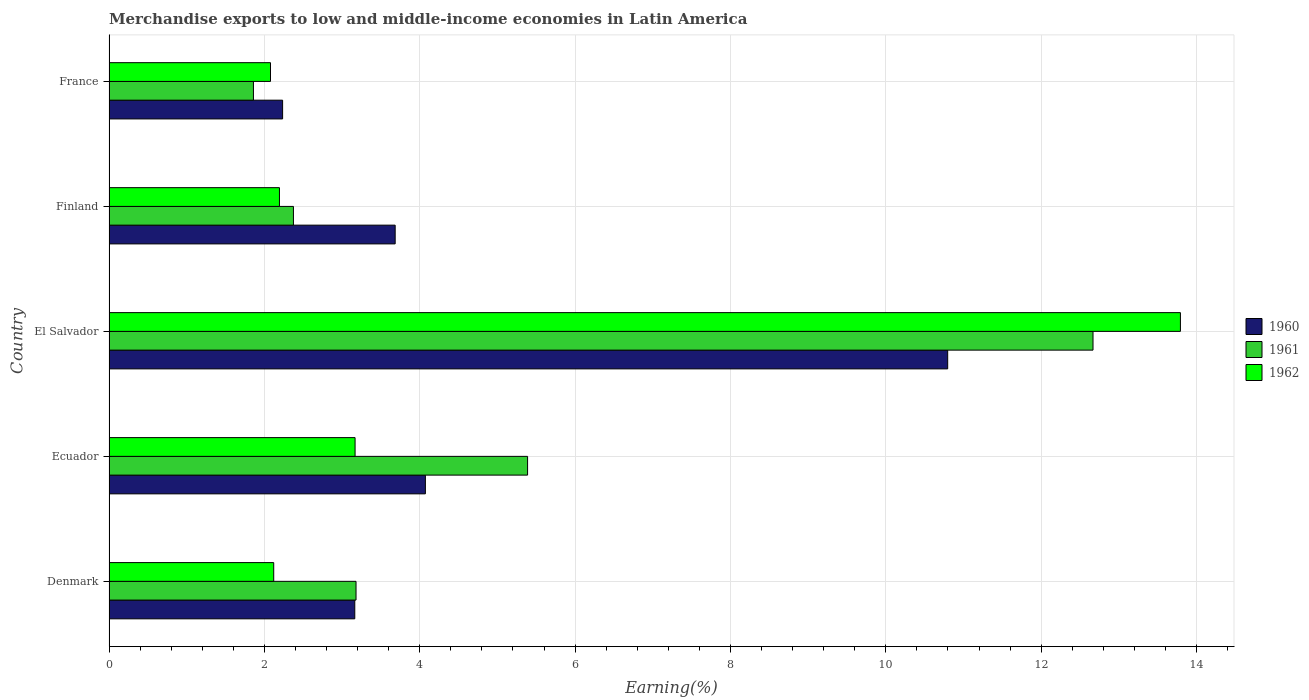How many different coloured bars are there?
Your answer should be compact. 3. Are the number of bars per tick equal to the number of legend labels?
Offer a terse response. Yes. Are the number of bars on each tick of the Y-axis equal?
Offer a very short reply. Yes. How many bars are there on the 3rd tick from the bottom?
Your answer should be compact. 3. In how many cases, is the number of bars for a given country not equal to the number of legend labels?
Provide a succinct answer. 0. What is the percentage of amount earned from merchandise exports in 1961 in Ecuador?
Make the answer very short. 5.39. Across all countries, what is the maximum percentage of amount earned from merchandise exports in 1960?
Make the answer very short. 10.8. Across all countries, what is the minimum percentage of amount earned from merchandise exports in 1961?
Give a very brief answer. 1.86. In which country was the percentage of amount earned from merchandise exports in 1961 maximum?
Your answer should be compact. El Salvador. What is the total percentage of amount earned from merchandise exports in 1962 in the graph?
Offer a terse response. 23.35. What is the difference between the percentage of amount earned from merchandise exports in 1960 in Denmark and that in France?
Provide a short and direct response. 0.93. What is the difference between the percentage of amount earned from merchandise exports in 1962 in El Salvador and the percentage of amount earned from merchandise exports in 1960 in France?
Your answer should be compact. 11.56. What is the average percentage of amount earned from merchandise exports in 1961 per country?
Provide a succinct answer. 5.09. What is the difference between the percentage of amount earned from merchandise exports in 1962 and percentage of amount earned from merchandise exports in 1961 in Ecuador?
Offer a terse response. -2.22. What is the ratio of the percentage of amount earned from merchandise exports in 1960 in Ecuador to that in El Salvador?
Provide a short and direct response. 0.38. Is the percentage of amount earned from merchandise exports in 1961 in Denmark less than that in Ecuador?
Ensure brevity in your answer.  Yes. Is the difference between the percentage of amount earned from merchandise exports in 1962 in Denmark and Ecuador greater than the difference between the percentage of amount earned from merchandise exports in 1961 in Denmark and Ecuador?
Provide a short and direct response. Yes. What is the difference between the highest and the second highest percentage of amount earned from merchandise exports in 1961?
Your answer should be very brief. 7.28. What is the difference between the highest and the lowest percentage of amount earned from merchandise exports in 1961?
Provide a succinct answer. 10.81. What does the 3rd bar from the top in El Salvador represents?
Your answer should be very brief. 1960. What does the 3rd bar from the bottom in Denmark represents?
Provide a short and direct response. 1962. Is it the case that in every country, the sum of the percentage of amount earned from merchandise exports in 1960 and percentage of amount earned from merchandise exports in 1961 is greater than the percentage of amount earned from merchandise exports in 1962?
Offer a terse response. Yes. Are all the bars in the graph horizontal?
Provide a short and direct response. Yes. How many countries are there in the graph?
Provide a succinct answer. 5. What is the difference between two consecutive major ticks on the X-axis?
Your answer should be very brief. 2. Does the graph contain any zero values?
Provide a short and direct response. No. Where does the legend appear in the graph?
Give a very brief answer. Center right. How many legend labels are there?
Ensure brevity in your answer.  3. How are the legend labels stacked?
Your response must be concise. Vertical. What is the title of the graph?
Provide a short and direct response. Merchandise exports to low and middle-income economies in Latin America. Does "1990" appear as one of the legend labels in the graph?
Offer a terse response. No. What is the label or title of the X-axis?
Your answer should be very brief. Earning(%). What is the label or title of the Y-axis?
Your answer should be very brief. Country. What is the Earning(%) of 1960 in Denmark?
Provide a succinct answer. 3.16. What is the Earning(%) in 1961 in Denmark?
Make the answer very short. 3.18. What is the Earning(%) in 1962 in Denmark?
Keep it short and to the point. 2.12. What is the Earning(%) in 1960 in Ecuador?
Ensure brevity in your answer.  4.07. What is the Earning(%) of 1961 in Ecuador?
Make the answer very short. 5.39. What is the Earning(%) in 1962 in Ecuador?
Your answer should be very brief. 3.17. What is the Earning(%) in 1960 in El Salvador?
Offer a terse response. 10.8. What is the Earning(%) of 1961 in El Salvador?
Your answer should be very brief. 12.67. What is the Earning(%) of 1962 in El Salvador?
Provide a short and direct response. 13.79. What is the Earning(%) of 1960 in Finland?
Ensure brevity in your answer.  3.68. What is the Earning(%) in 1961 in Finland?
Your response must be concise. 2.37. What is the Earning(%) of 1962 in Finland?
Offer a very short reply. 2.19. What is the Earning(%) of 1960 in France?
Offer a terse response. 2.23. What is the Earning(%) in 1961 in France?
Ensure brevity in your answer.  1.86. What is the Earning(%) in 1962 in France?
Provide a short and direct response. 2.08. Across all countries, what is the maximum Earning(%) in 1960?
Ensure brevity in your answer.  10.8. Across all countries, what is the maximum Earning(%) of 1961?
Offer a very short reply. 12.67. Across all countries, what is the maximum Earning(%) in 1962?
Ensure brevity in your answer.  13.79. Across all countries, what is the minimum Earning(%) in 1960?
Offer a very short reply. 2.23. Across all countries, what is the minimum Earning(%) in 1961?
Give a very brief answer. 1.86. Across all countries, what is the minimum Earning(%) in 1962?
Offer a terse response. 2.08. What is the total Earning(%) of 1960 in the graph?
Provide a succinct answer. 23.95. What is the total Earning(%) in 1961 in the graph?
Your answer should be very brief. 25.47. What is the total Earning(%) of 1962 in the graph?
Your answer should be very brief. 23.35. What is the difference between the Earning(%) in 1960 in Denmark and that in Ecuador?
Ensure brevity in your answer.  -0.91. What is the difference between the Earning(%) of 1961 in Denmark and that in Ecuador?
Offer a terse response. -2.21. What is the difference between the Earning(%) in 1962 in Denmark and that in Ecuador?
Your response must be concise. -1.05. What is the difference between the Earning(%) of 1960 in Denmark and that in El Salvador?
Offer a terse response. -7.63. What is the difference between the Earning(%) of 1961 in Denmark and that in El Salvador?
Make the answer very short. -9.49. What is the difference between the Earning(%) of 1962 in Denmark and that in El Salvador?
Your response must be concise. -11.67. What is the difference between the Earning(%) in 1960 in Denmark and that in Finland?
Offer a terse response. -0.52. What is the difference between the Earning(%) of 1961 in Denmark and that in Finland?
Your answer should be compact. 0.81. What is the difference between the Earning(%) in 1962 in Denmark and that in Finland?
Make the answer very short. -0.07. What is the difference between the Earning(%) of 1960 in Denmark and that in France?
Give a very brief answer. 0.93. What is the difference between the Earning(%) in 1961 in Denmark and that in France?
Give a very brief answer. 1.32. What is the difference between the Earning(%) in 1962 in Denmark and that in France?
Your response must be concise. 0.04. What is the difference between the Earning(%) of 1960 in Ecuador and that in El Salvador?
Offer a terse response. -6.72. What is the difference between the Earning(%) of 1961 in Ecuador and that in El Salvador?
Your response must be concise. -7.28. What is the difference between the Earning(%) in 1962 in Ecuador and that in El Salvador?
Your answer should be compact. -10.63. What is the difference between the Earning(%) in 1960 in Ecuador and that in Finland?
Offer a very short reply. 0.39. What is the difference between the Earning(%) in 1961 in Ecuador and that in Finland?
Keep it short and to the point. 3.01. What is the difference between the Earning(%) in 1962 in Ecuador and that in Finland?
Keep it short and to the point. 0.97. What is the difference between the Earning(%) of 1960 in Ecuador and that in France?
Offer a very short reply. 1.84. What is the difference between the Earning(%) of 1961 in Ecuador and that in France?
Make the answer very short. 3.53. What is the difference between the Earning(%) of 1962 in Ecuador and that in France?
Your response must be concise. 1.09. What is the difference between the Earning(%) in 1960 in El Salvador and that in Finland?
Keep it short and to the point. 7.11. What is the difference between the Earning(%) of 1961 in El Salvador and that in Finland?
Make the answer very short. 10.29. What is the difference between the Earning(%) in 1962 in El Salvador and that in Finland?
Give a very brief answer. 11.6. What is the difference between the Earning(%) in 1960 in El Salvador and that in France?
Your answer should be very brief. 8.56. What is the difference between the Earning(%) in 1961 in El Salvador and that in France?
Provide a succinct answer. 10.81. What is the difference between the Earning(%) of 1962 in El Salvador and that in France?
Provide a short and direct response. 11.71. What is the difference between the Earning(%) of 1960 in Finland and that in France?
Your answer should be compact. 1.45. What is the difference between the Earning(%) of 1961 in Finland and that in France?
Offer a very short reply. 0.51. What is the difference between the Earning(%) of 1962 in Finland and that in France?
Your response must be concise. 0.12. What is the difference between the Earning(%) of 1960 in Denmark and the Earning(%) of 1961 in Ecuador?
Provide a succinct answer. -2.22. What is the difference between the Earning(%) in 1960 in Denmark and the Earning(%) in 1962 in Ecuador?
Offer a very short reply. -0. What is the difference between the Earning(%) of 1961 in Denmark and the Earning(%) of 1962 in Ecuador?
Your response must be concise. 0.01. What is the difference between the Earning(%) of 1960 in Denmark and the Earning(%) of 1961 in El Salvador?
Provide a short and direct response. -9.5. What is the difference between the Earning(%) in 1960 in Denmark and the Earning(%) in 1962 in El Salvador?
Your response must be concise. -10.63. What is the difference between the Earning(%) of 1961 in Denmark and the Earning(%) of 1962 in El Salvador?
Provide a short and direct response. -10.61. What is the difference between the Earning(%) in 1960 in Denmark and the Earning(%) in 1961 in Finland?
Provide a succinct answer. 0.79. What is the difference between the Earning(%) in 1960 in Denmark and the Earning(%) in 1962 in Finland?
Provide a short and direct response. 0.97. What is the difference between the Earning(%) in 1961 in Denmark and the Earning(%) in 1962 in Finland?
Make the answer very short. 0.99. What is the difference between the Earning(%) in 1960 in Denmark and the Earning(%) in 1961 in France?
Your answer should be very brief. 1.3. What is the difference between the Earning(%) of 1960 in Denmark and the Earning(%) of 1962 in France?
Keep it short and to the point. 1.09. What is the difference between the Earning(%) of 1961 in Denmark and the Earning(%) of 1962 in France?
Provide a short and direct response. 1.1. What is the difference between the Earning(%) of 1960 in Ecuador and the Earning(%) of 1961 in El Salvador?
Make the answer very short. -8.59. What is the difference between the Earning(%) of 1960 in Ecuador and the Earning(%) of 1962 in El Salvador?
Your answer should be very brief. -9.72. What is the difference between the Earning(%) in 1961 in Ecuador and the Earning(%) in 1962 in El Salvador?
Your answer should be very brief. -8.4. What is the difference between the Earning(%) in 1960 in Ecuador and the Earning(%) in 1961 in Finland?
Your response must be concise. 1.7. What is the difference between the Earning(%) of 1960 in Ecuador and the Earning(%) of 1962 in Finland?
Ensure brevity in your answer.  1.88. What is the difference between the Earning(%) of 1961 in Ecuador and the Earning(%) of 1962 in Finland?
Offer a very short reply. 3.19. What is the difference between the Earning(%) of 1960 in Ecuador and the Earning(%) of 1961 in France?
Keep it short and to the point. 2.21. What is the difference between the Earning(%) of 1960 in Ecuador and the Earning(%) of 1962 in France?
Give a very brief answer. 1.99. What is the difference between the Earning(%) of 1961 in Ecuador and the Earning(%) of 1962 in France?
Ensure brevity in your answer.  3.31. What is the difference between the Earning(%) in 1960 in El Salvador and the Earning(%) in 1961 in Finland?
Ensure brevity in your answer.  8.42. What is the difference between the Earning(%) in 1960 in El Salvador and the Earning(%) in 1962 in Finland?
Give a very brief answer. 8.6. What is the difference between the Earning(%) in 1961 in El Salvador and the Earning(%) in 1962 in Finland?
Give a very brief answer. 10.47. What is the difference between the Earning(%) of 1960 in El Salvador and the Earning(%) of 1961 in France?
Make the answer very short. 8.94. What is the difference between the Earning(%) in 1960 in El Salvador and the Earning(%) in 1962 in France?
Provide a succinct answer. 8.72. What is the difference between the Earning(%) in 1961 in El Salvador and the Earning(%) in 1962 in France?
Provide a short and direct response. 10.59. What is the difference between the Earning(%) in 1960 in Finland and the Earning(%) in 1961 in France?
Your response must be concise. 1.82. What is the difference between the Earning(%) of 1960 in Finland and the Earning(%) of 1962 in France?
Offer a terse response. 1.6. What is the difference between the Earning(%) in 1961 in Finland and the Earning(%) in 1962 in France?
Your answer should be very brief. 0.3. What is the average Earning(%) in 1960 per country?
Make the answer very short. 4.79. What is the average Earning(%) in 1961 per country?
Your answer should be very brief. 5.09. What is the average Earning(%) in 1962 per country?
Provide a succinct answer. 4.67. What is the difference between the Earning(%) of 1960 and Earning(%) of 1961 in Denmark?
Keep it short and to the point. -0.02. What is the difference between the Earning(%) of 1960 and Earning(%) of 1962 in Denmark?
Your answer should be very brief. 1.04. What is the difference between the Earning(%) in 1961 and Earning(%) in 1962 in Denmark?
Offer a very short reply. 1.06. What is the difference between the Earning(%) in 1960 and Earning(%) in 1961 in Ecuador?
Your response must be concise. -1.32. What is the difference between the Earning(%) of 1960 and Earning(%) of 1962 in Ecuador?
Ensure brevity in your answer.  0.91. What is the difference between the Earning(%) of 1961 and Earning(%) of 1962 in Ecuador?
Your response must be concise. 2.22. What is the difference between the Earning(%) of 1960 and Earning(%) of 1961 in El Salvador?
Your response must be concise. -1.87. What is the difference between the Earning(%) in 1960 and Earning(%) in 1962 in El Salvador?
Keep it short and to the point. -3. What is the difference between the Earning(%) in 1961 and Earning(%) in 1962 in El Salvador?
Ensure brevity in your answer.  -1.13. What is the difference between the Earning(%) of 1960 and Earning(%) of 1961 in Finland?
Your answer should be compact. 1.31. What is the difference between the Earning(%) of 1960 and Earning(%) of 1962 in Finland?
Give a very brief answer. 1.49. What is the difference between the Earning(%) of 1961 and Earning(%) of 1962 in Finland?
Give a very brief answer. 0.18. What is the difference between the Earning(%) of 1960 and Earning(%) of 1961 in France?
Provide a short and direct response. 0.38. What is the difference between the Earning(%) in 1960 and Earning(%) in 1962 in France?
Ensure brevity in your answer.  0.16. What is the difference between the Earning(%) of 1961 and Earning(%) of 1962 in France?
Offer a very short reply. -0.22. What is the ratio of the Earning(%) in 1960 in Denmark to that in Ecuador?
Make the answer very short. 0.78. What is the ratio of the Earning(%) of 1961 in Denmark to that in Ecuador?
Provide a short and direct response. 0.59. What is the ratio of the Earning(%) of 1962 in Denmark to that in Ecuador?
Keep it short and to the point. 0.67. What is the ratio of the Earning(%) in 1960 in Denmark to that in El Salvador?
Your response must be concise. 0.29. What is the ratio of the Earning(%) in 1961 in Denmark to that in El Salvador?
Make the answer very short. 0.25. What is the ratio of the Earning(%) in 1962 in Denmark to that in El Salvador?
Ensure brevity in your answer.  0.15. What is the ratio of the Earning(%) of 1960 in Denmark to that in Finland?
Your answer should be very brief. 0.86. What is the ratio of the Earning(%) of 1961 in Denmark to that in Finland?
Your answer should be compact. 1.34. What is the ratio of the Earning(%) in 1962 in Denmark to that in Finland?
Your response must be concise. 0.97. What is the ratio of the Earning(%) of 1960 in Denmark to that in France?
Ensure brevity in your answer.  1.42. What is the ratio of the Earning(%) of 1961 in Denmark to that in France?
Offer a terse response. 1.71. What is the ratio of the Earning(%) of 1962 in Denmark to that in France?
Your answer should be very brief. 1.02. What is the ratio of the Earning(%) in 1960 in Ecuador to that in El Salvador?
Your answer should be compact. 0.38. What is the ratio of the Earning(%) of 1961 in Ecuador to that in El Salvador?
Provide a short and direct response. 0.43. What is the ratio of the Earning(%) of 1962 in Ecuador to that in El Salvador?
Make the answer very short. 0.23. What is the ratio of the Earning(%) of 1960 in Ecuador to that in Finland?
Your response must be concise. 1.11. What is the ratio of the Earning(%) in 1961 in Ecuador to that in Finland?
Your response must be concise. 2.27. What is the ratio of the Earning(%) in 1962 in Ecuador to that in Finland?
Make the answer very short. 1.44. What is the ratio of the Earning(%) in 1960 in Ecuador to that in France?
Offer a very short reply. 1.82. What is the ratio of the Earning(%) of 1961 in Ecuador to that in France?
Provide a short and direct response. 2.9. What is the ratio of the Earning(%) in 1962 in Ecuador to that in France?
Ensure brevity in your answer.  1.52. What is the ratio of the Earning(%) in 1960 in El Salvador to that in Finland?
Offer a very short reply. 2.93. What is the ratio of the Earning(%) of 1961 in El Salvador to that in Finland?
Your answer should be compact. 5.34. What is the ratio of the Earning(%) of 1962 in El Salvador to that in Finland?
Offer a very short reply. 6.29. What is the ratio of the Earning(%) of 1960 in El Salvador to that in France?
Ensure brevity in your answer.  4.83. What is the ratio of the Earning(%) in 1961 in El Salvador to that in France?
Provide a short and direct response. 6.81. What is the ratio of the Earning(%) of 1962 in El Salvador to that in France?
Provide a short and direct response. 6.63. What is the ratio of the Earning(%) of 1960 in Finland to that in France?
Make the answer very short. 1.65. What is the ratio of the Earning(%) of 1961 in Finland to that in France?
Ensure brevity in your answer.  1.28. What is the ratio of the Earning(%) of 1962 in Finland to that in France?
Provide a short and direct response. 1.06. What is the difference between the highest and the second highest Earning(%) of 1960?
Your response must be concise. 6.72. What is the difference between the highest and the second highest Earning(%) of 1961?
Offer a very short reply. 7.28. What is the difference between the highest and the second highest Earning(%) in 1962?
Provide a short and direct response. 10.63. What is the difference between the highest and the lowest Earning(%) in 1960?
Your answer should be very brief. 8.56. What is the difference between the highest and the lowest Earning(%) in 1961?
Offer a very short reply. 10.81. What is the difference between the highest and the lowest Earning(%) of 1962?
Make the answer very short. 11.71. 